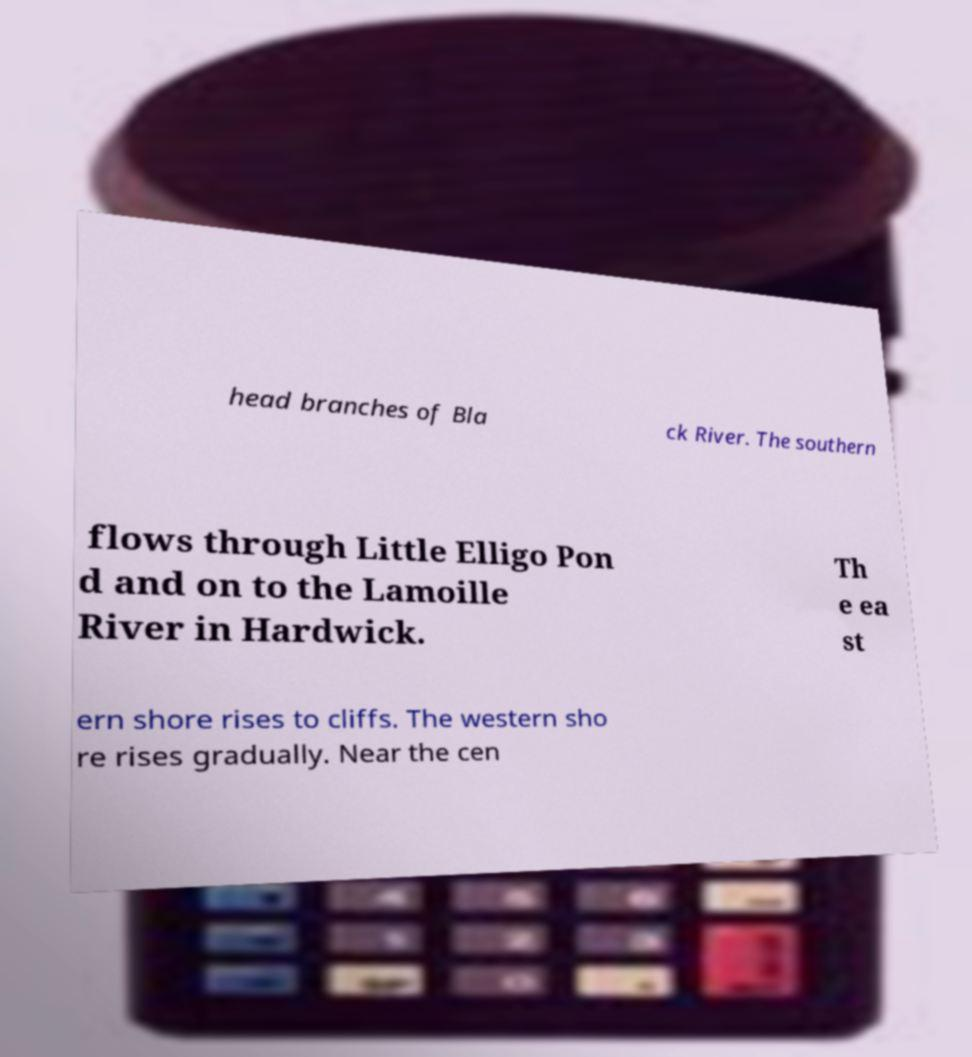Could you extract and type out the text from this image? head branches of Bla ck River. The southern flows through Little Elligo Pon d and on to the Lamoille River in Hardwick. Th e ea st ern shore rises to cliffs. The western sho re rises gradually. Near the cen 